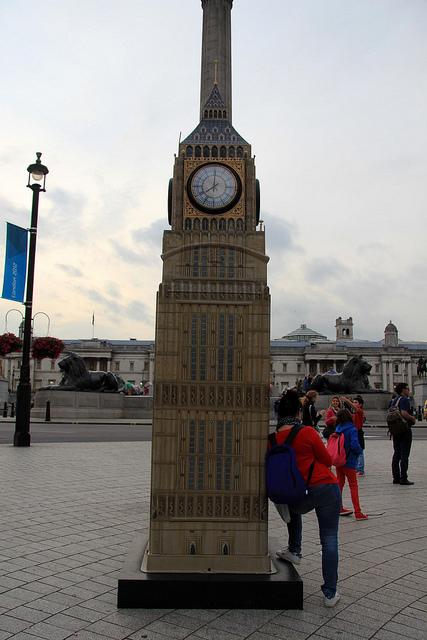Where is the man standing?
Give a very brief answer. Next to clock. Is this a lake?
Quick response, please. No. How many red shirts are there?
Write a very short answer. 2. What color is the backpack?
Keep it brief. Blue. What are the statues in the background of?
Be succinct. Lions. 